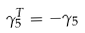<formula> <loc_0><loc_0><loc_500><loc_500>\gamma _ { 5 } ^ { T } = - \gamma _ { 5 }</formula> 